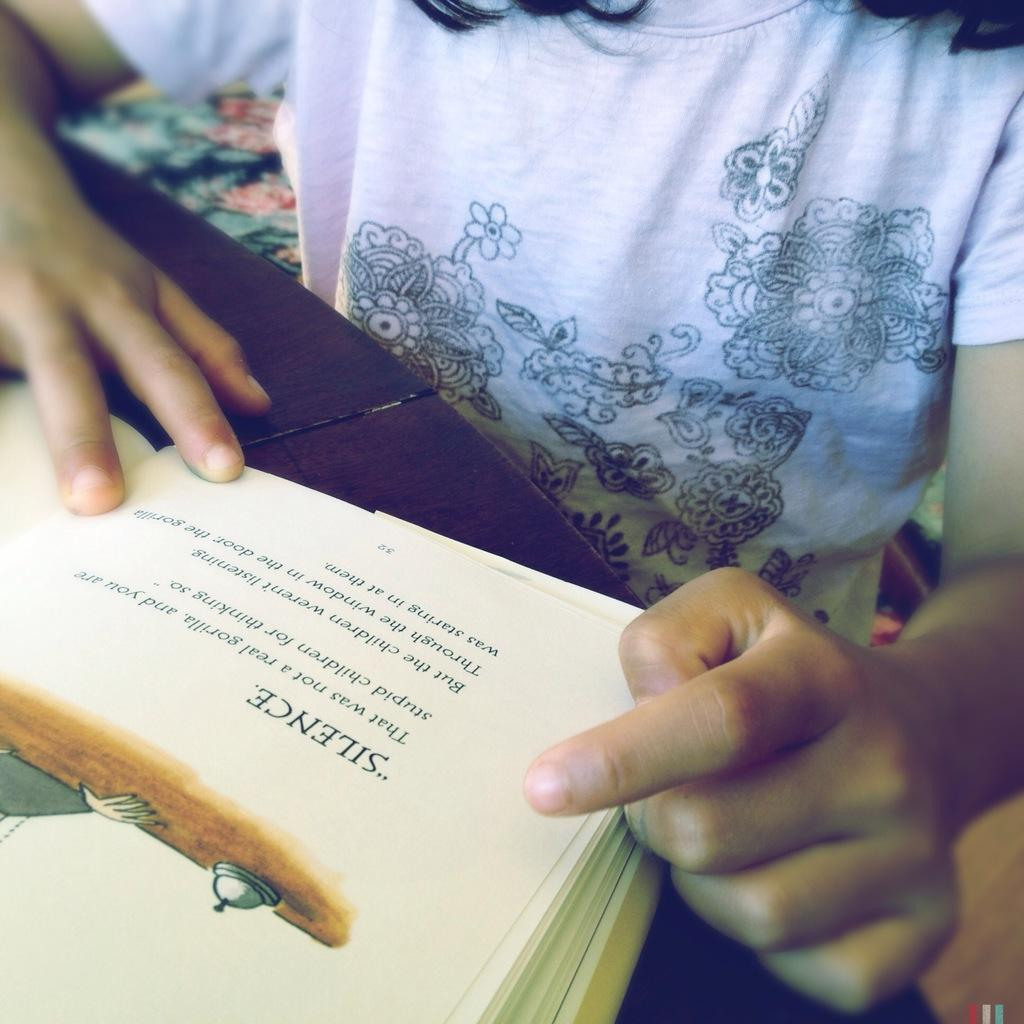<image>
Describe the image concisely. A child reads a section of a book called Silence. 